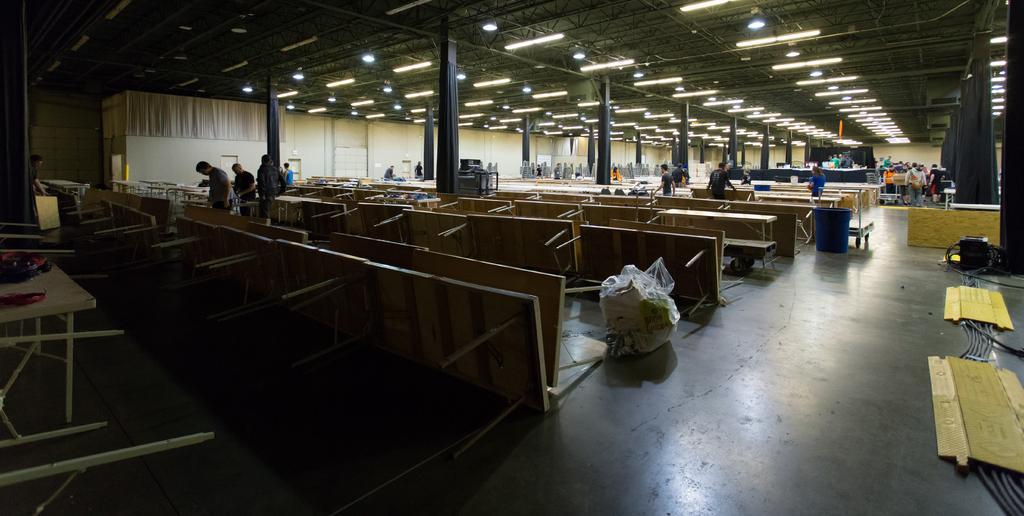Please provide a concise description of this image. There are many tables. Also there are many people. There is a dustbin. Also there is a plastic cover with some items. There are pillars. On the ceiling there are lights. On the floor there are wires. In the back there is a wall with curtain. 